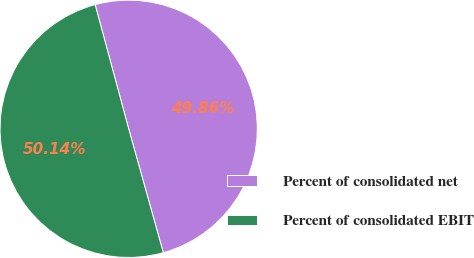Convert chart to OTSL. <chart><loc_0><loc_0><loc_500><loc_500><pie_chart><fcel>Percent of consolidated net<fcel>Percent of consolidated EBIT<nl><fcel>49.86%<fcel>50.14%<nl></chart> 